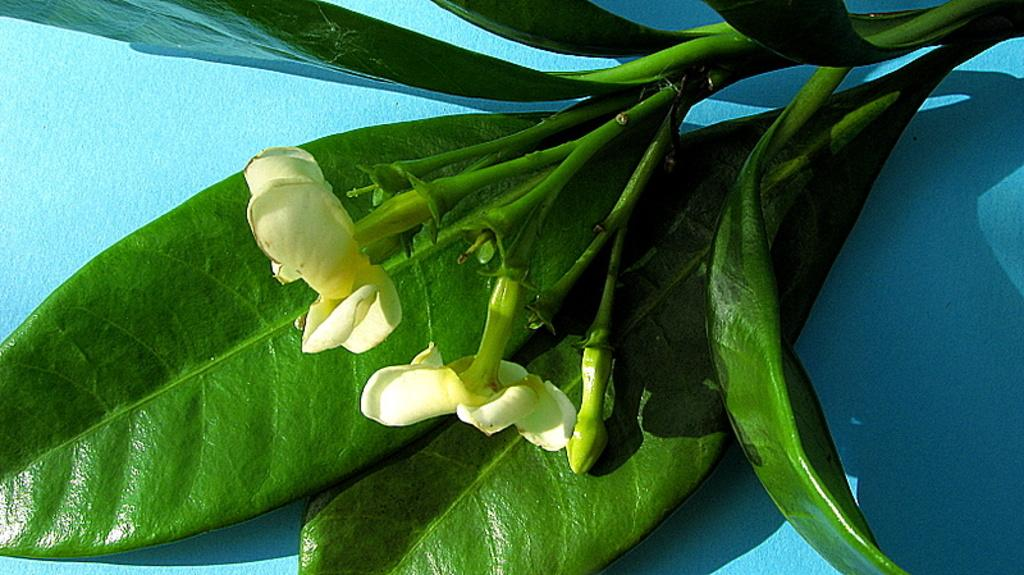How many flowers are visible in the image? There are two white flowers in the image. What is the color of the flowers? The flowers are white. Where are the flowers located? The flowers are on a plant. What is the background of the image? The plant is in front of a blue wall. Can you tell me how many stalks of celery are in the image? There is no celery present in the image; it features two white flowers on a plant in front of a blue wall. 